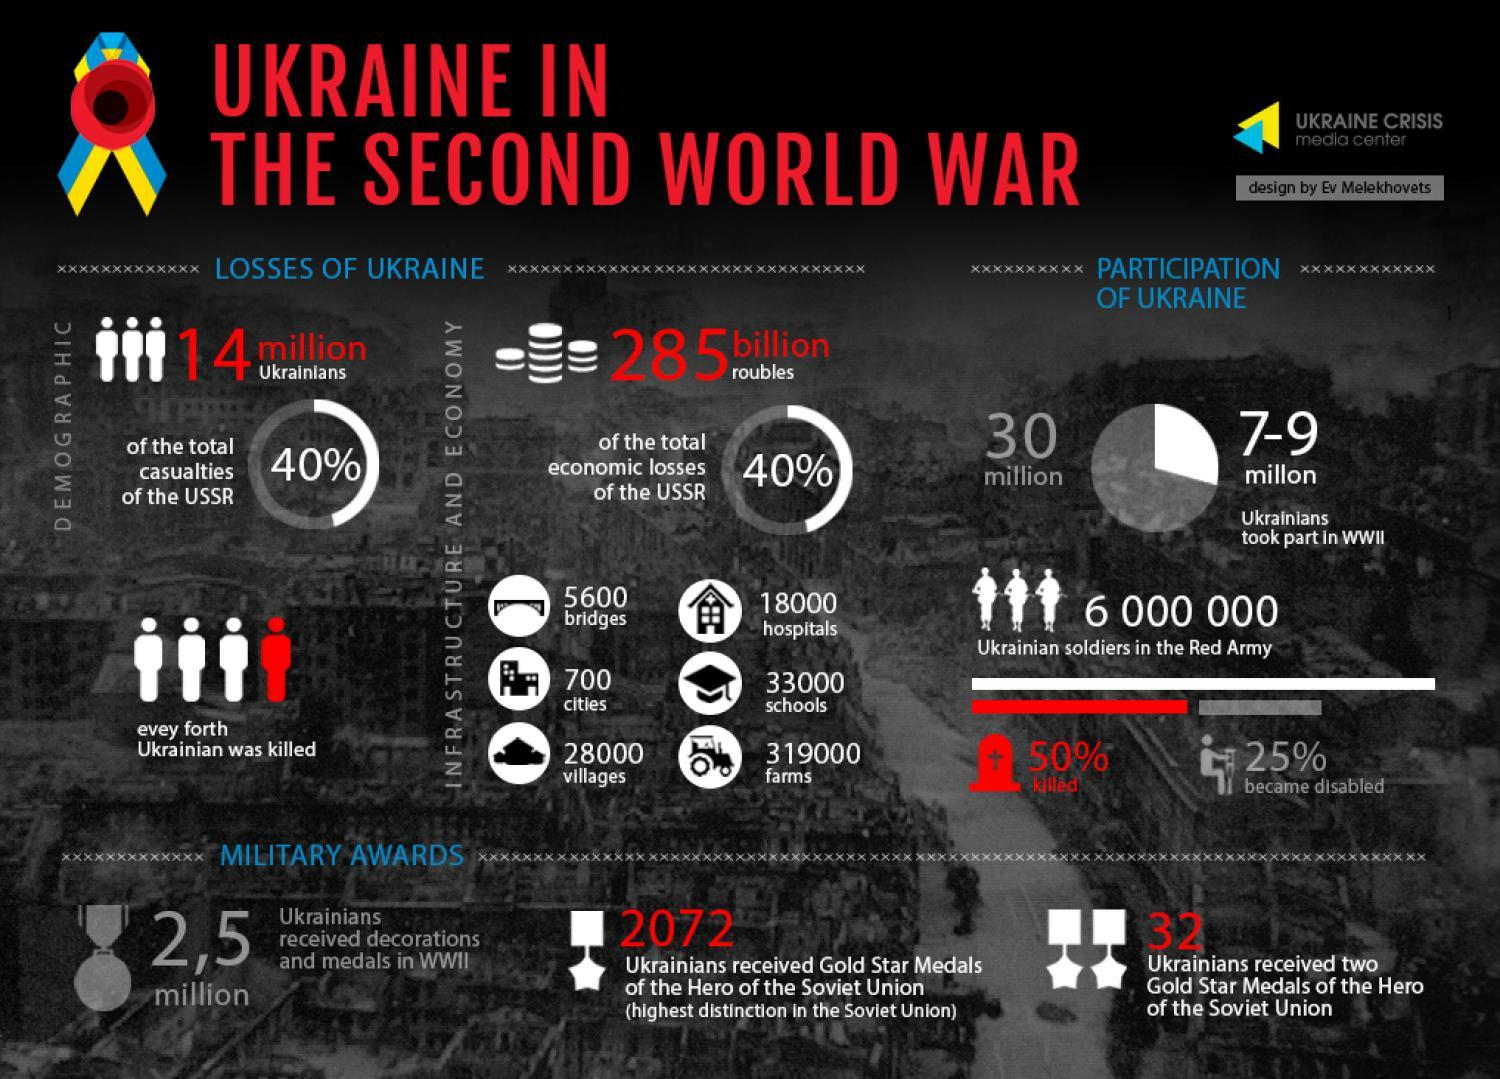How many hospitals were destroyed in Ukraine during the Second World War?
Answer the question with a short phrase. 18000 How many Ukrainians received two Gold Star medal of the hero of the soviet union in the Second World War? 32 What percent of Ukrainian soldiers in the Red Army died in the Second World War? 50% How many schools were destroyed in Ukraine during the Second World War? 33000 